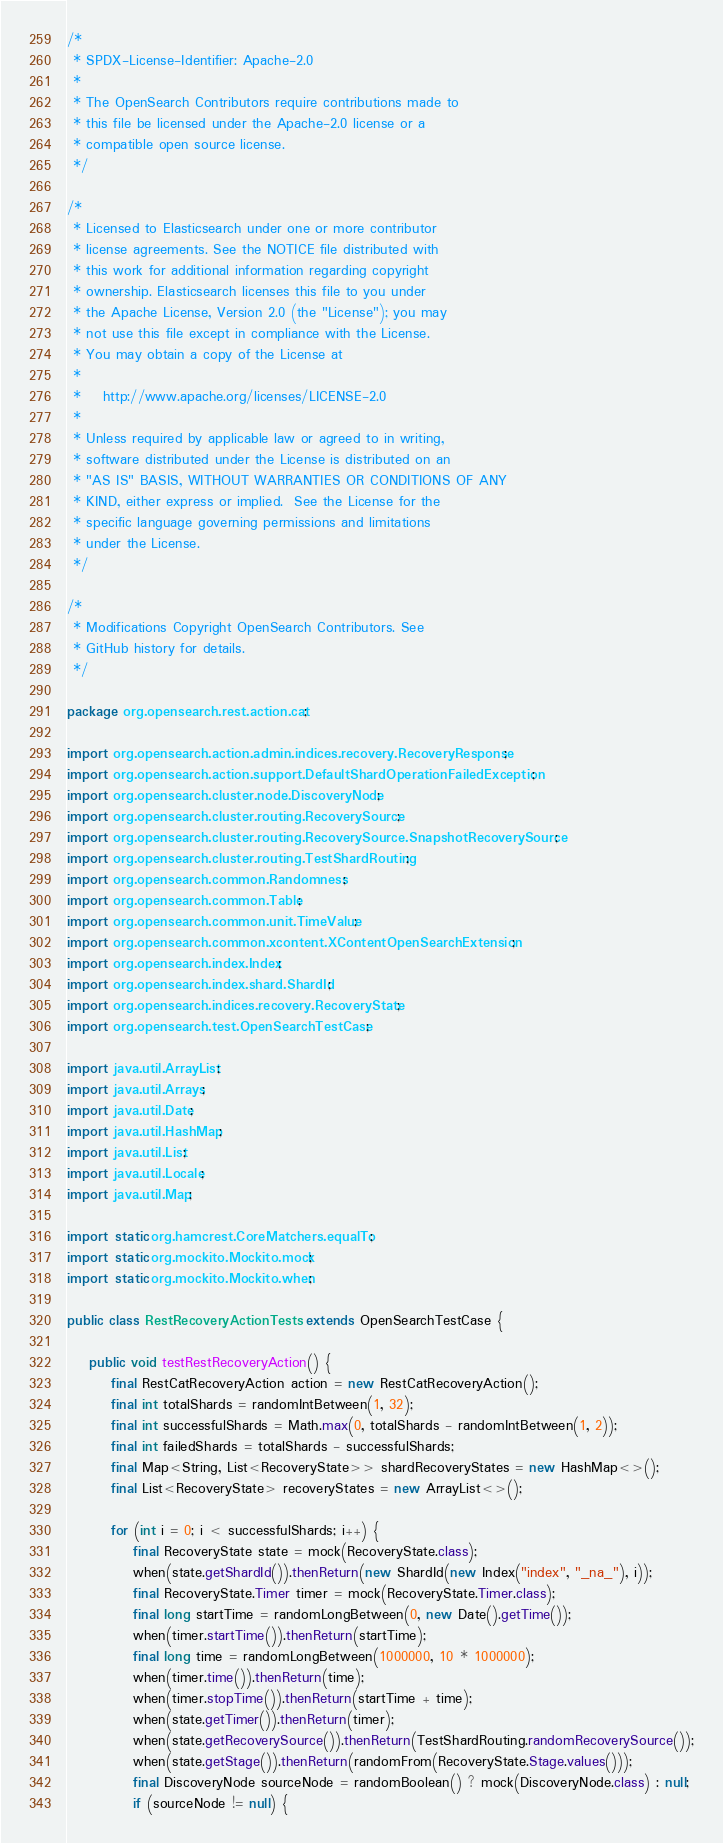Convert code to text. <code><loc_0><loc_0><loc_500><loc_500><_Java_>/*
 * SPDX-License-Identifier: Apache-2.0
 *
 * The OpenSearch Contributors require contributions made to
 * this file be licensed under the Apache-2.0 license or a
 * compatible open source license.
 */

/*
 * Licensed to Elasticsearch under one or more contributor
 * license agreements. See the NOTICE file distributed with
 * this work for additional information regarding copyright
 * ownership. Elasticsearch licenses this file to you under
 * the Apache License, Version 2.0 (the "License"); you may
 * not use this file except in compliance with the License.
 * You may obtain a copy of the License at
 *
 *    http://www.apache.org/licenses/LICENSE-2.0
 *
 * Unless required by applicable law or agreed to in writing,
 * software distributed under the License is distributed on an
 * "AS IS" BASIS, WITHOUT WARRANTIES OR CONDITIONS OF ANY
 * KIND, either express or implied.  See the License for the
 * specific language governing permissions and limitations
 * under the License.
 */

/*
 * Modifications Copyright OpenSearch Contributors. See
 * GitHub history for details.
 */

package org.opensearch.rest.action.cat;

import org.opensearch.action.admin.indices.recovery.RecoveryResponse;
import org.opensearch.action.support.DefaultShardOperationFailedException;
import org.opensearch.cluster.node.DiscoveryNode;
import org.opensearch.cluster.routing.RecoverySource;
import org.opensearch.cluster.routing.RecoverySource.SnapshotRecoverySource;
import org.opensearch.cluster.routing.TestShardRouting;
import org.opensearch.common.Randomness;
import org.opensearch.common.Table;
import org.opensearch.common.unit.TimeValue;
import org.opensearch.common.xcontent.XContentOpenSearchExtension;
import org.opensearch.index.Index;
import org.opensearch.index.shard.ShardId;
import org.opensearch.indices.recovery.RecoveryState;
import org.opensearch.test.OpenSearchTestCase;

import java.util.ArrayList;
import java.util.Arrays;
import java.util.Date;
import java.util.HashMap;
import java.util.List;
import java.util.Locale;
import java.util.Map;

import static org.hamcrest.CoreMatchers.equalTo;
import static org.mockito.Mockito.mock;
import static org.mockito.Mockito.when;

public class RestRecoveryActionTests extends OpenSearchTestCase {

    public void testRestRecoveryAction() {
        final RestCatRecoveryAction action = new RestCatRecoveryAction();
        final int totalShards = randomIntBetween(1, 32);
        final int successfulShards = Math.max(0, totalShards - randomIntBetween(1, 2));
        final int failedShards = totalShards - successfulShards;
        final Map<String, List<RecoveryState>> shardRecoveryStates = new HashMap<>();
        final List<RecoveryState> recoveryStates = new ArrayList<>();

        for (int i = 0; i < successfulShards; i++) {
            final RecoveryState state = mock(RecoveryState.class);
            when(state.getShardId()).thenReturn(new ShardId(new Index("index", "_na_"), i));
            final RecoveryState.Timer timer = mock(RecoveryState.Timer.class);
            final long startTime = randomLongBetween(0, new Date().getTime());
            when(timer.startTime()).thenReturn(startTime);
            final long time = randomLongBetween(1000000, 10 * 1000000);
            when(timer.time()).thenReturn(time);
            when(timer.stopTime()).thenReturn(startTime + time);
            when(state.getTimer()).thenReturn(timer);
            when(state.getRecoverySource()).thenReturn(TestShardRouting.randomRecoverySource());
            when(state.getStage()).thenReturn(randomFrom(RecoveryState.Stage.values()));
            final DiscoveryNode sourceNode = randomBoolean() ? mock(DiscoveryNode.class) : null;
            if (sourceNode != null) {</code> 